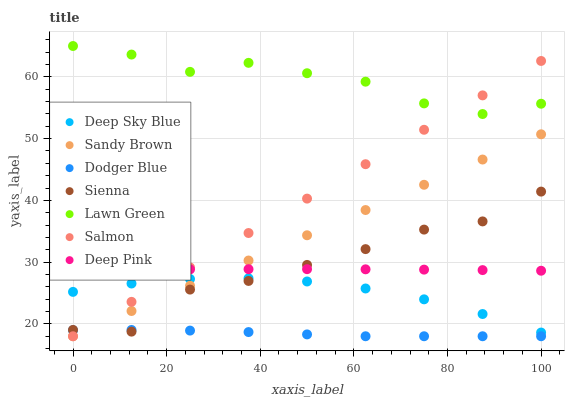Does Dodger Blue have the minimum area under the curve?
Answer yes or no. Yes. Does Lawn Green have the maximum area under the curve?
Answer yes or no. Yes. Does Deep Pink have the minimum area under the curve?
Answer yes or no. No. Does Deep Pink have the maximum area under the curve?
Answer yes or no. No. Is Salmon the smoothest?
Answer yes or no. Yes. Is Sienna the roughest?
Answer yes or no. Yes. Is Deep Pink the smoothest?
Answer yes or no. No. Is Deep Pink the roughest?
Answer yes or no. No. Does Salmon have the lowest value?
Answer yes or no. Yes. Does Deep Pink have the lowest value?
Answer yes or no. No. Does Lawn Green have the highest value?
Answer yes or no. Yes. Does Deep Pink have the highest value?
Answer yes or no. No. Is Dodger Blue less than Lawn Green?
Answer yes or no. Yes. Is Lawn Green greater than Sienna?
Answer yes or no. Yes. Does Salmon intersect Sandy Brown?
Answer yes or no. Yes. Is Salmon less than Sandy Brown?
Answer yes or no. No. Is Salmon greater than Sandy Brown?
Answer yes or no. No. Does Dodger Blue intersect Lawn Green?
Answer yes or no. No. 